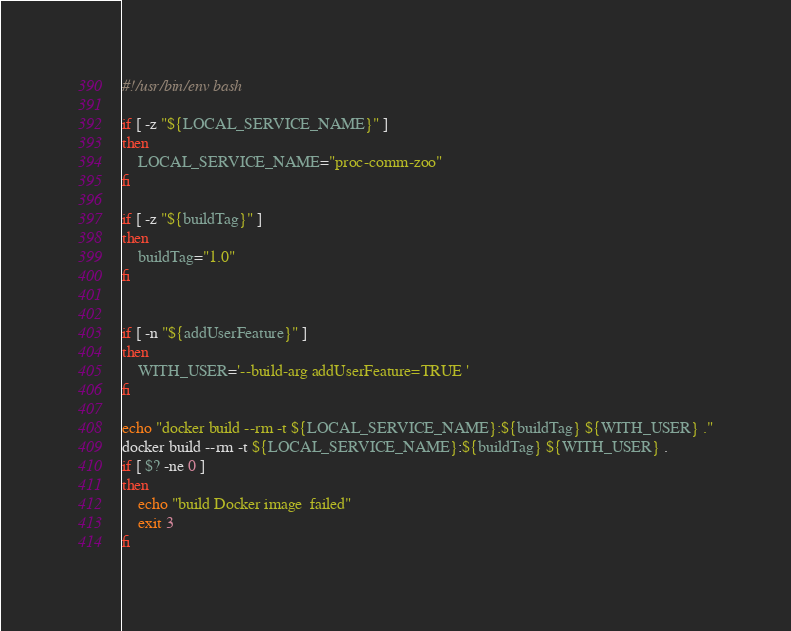Convert code to text. <code><loc_0><loc_0><loc_500><loc_500><_Bash_>#!/usr/bin/env bash

if [ -z "${LOCAL_SERVICE_NAME}" ]
then
	LOCAL_SERVICE_NAME="proc-comm-zoo"
fi

if [ -z "${buildTag}" ]
then
	buildTag="1.0"
fi


if [ -n "${addUserFeature}" ]
then
	WITH_USER='--build-arg addUserFeature=TRUE '
fi

echo "docker build --rm -t ${LOCAL_SERVICE_NAME}:${buildTag} ${WITH_USER} ."
docker build --rm -t ${LOCAL_SERVICE_NAME}:${buildTag} ${WITH_USER} .
if [ $? -ne 0 ]
then
	echo "build Docker image  failed"
	exit 3
fi


</code> 